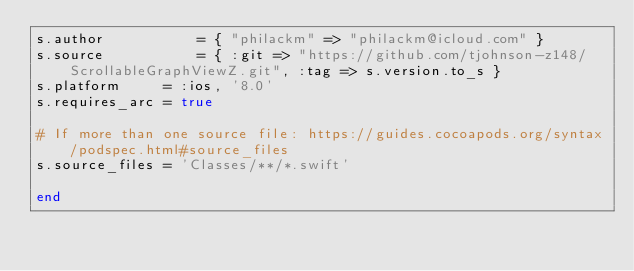Convert code to text. <code><loc_0><loc_0><loc_500><loc_500><_Ruby_>s.author           = { "philackm" => "philackm@icloud.com" }
s.source           = { :git => "https://github.com/tjohnson-z148/ScrollableGraphViewZ.git", :tag => s.version.to_s }
s.platform     = :ios, '8.0'
s.requires_arc = true

# If more than one source file: https://guides.cocoapods.org/syntax/podspec.html#source_files
s.source_files = 'Classes/**/*.swift'

end
</code> 